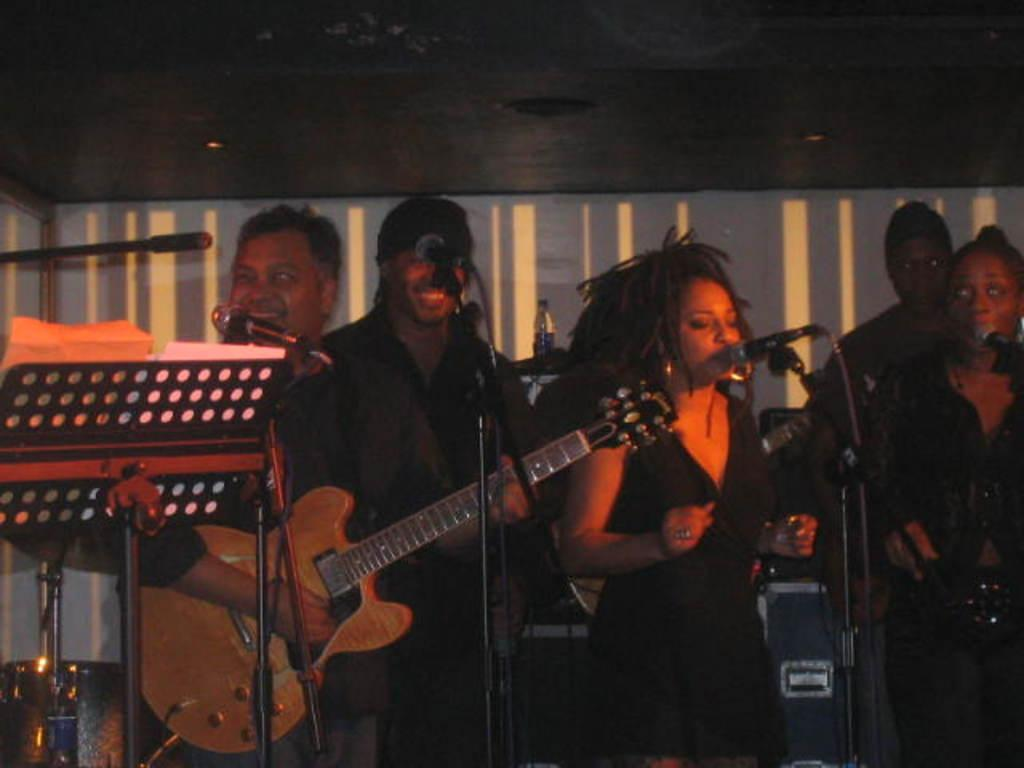How many musicians are present in the image? There are 4 musicians in the image. What are the musicians doing in the image? The musicians are standing and singing in the image. What instrument is one of the musicians playing? One person is holding a guitar and playing it. Can you describe the object in front of the musicians? They are in front of a microphone. What is attached to the board in the image? Papers are attached to the board. Can you see a squirrel wearing lace in the image? No, there is no squirrel or lace present in the image. What type of wall is visible behind the musicians? The image does not show a wall behind the musicians; it only shows the musicians, a microphone, a board with papers, and a person holding a guitar. 